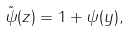<formula> <loc_0><loc_0><loc_500><loc_500>\tilde { \psi } ( z ) = 1 + \psi ( y ) ,</formula> 